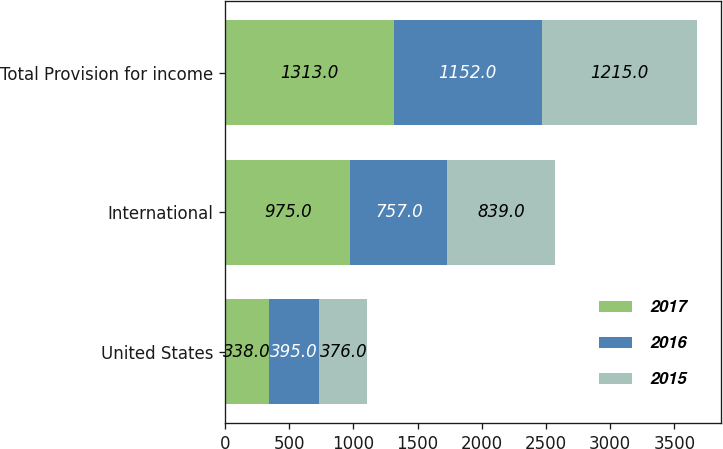Convert chart. <chart><loc_0><loc_0><loc_500><loc_500><stacked_bar_chart><ecel><fcel>United States<fcel>International<fcel>Total Provision for income<nl><fcel>2017<fcel>338<fcel>975<fcel>1313<nl><fcel>2016<fcel>395<fcel>757<fcel>1152<nl><fcel>2015<fcel>376<fcel>839<fcel>1215<nl></chart> 